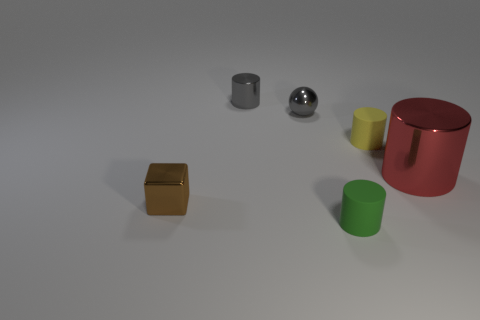Subtract 1 cylinders. How many cylinders are left? 3 Add 4 small yellow matte things. How many objects exist? 10 Subtract all blocks. How many objects are left? 5 Subtract all tiny rubber blocks. Subtract all tiny yellow rubber objects. How many objects are left? 5 Add 4 metallic cylinders. How many metallic cylinders are left? 6 Add 1 tiny gray objects. How many tiny gray objects exist? 3 Subtract 0 yellow cubes. How many objects are left? 6 